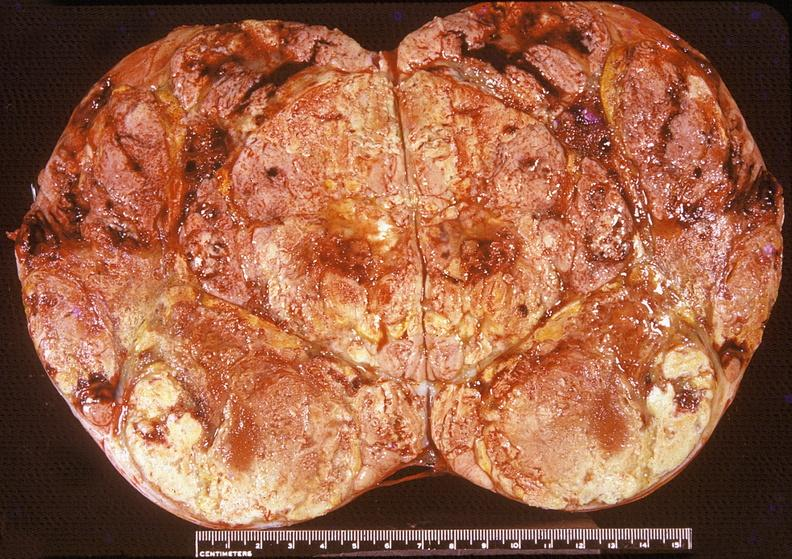s very good example present?
Answer the question using a single word or phrase. No 